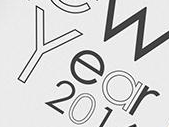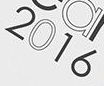Transcribe the words shown in these images in order, separated by a semicolon. Year; 2016 